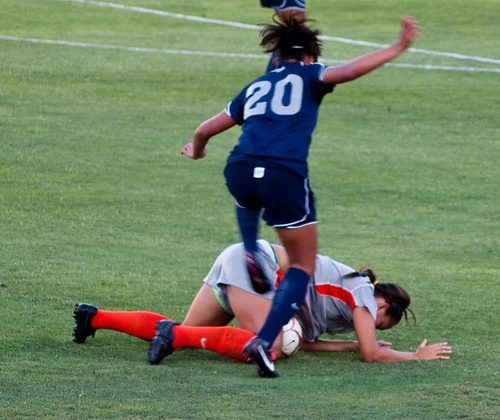<image>
Is the sock on the person? No. The sock is not positioned on the person. They may be near each other, but the sock is not supported by or resting on top of the person. Where is the shorts in relation to the shirt? Is it under the shirt? Yes. The shorts is positioned underneath the shirt, with the shirt above it in the vertical space. 